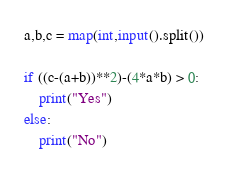<code> <loc_0><loc_0><loc_500><loc_500><_Python_>a,b,c = map(int,input().split())
 
if ((c-(a+b))**2)-(4*a*b) > 0:
    print("Yes")
else:
    print("No")</code> 